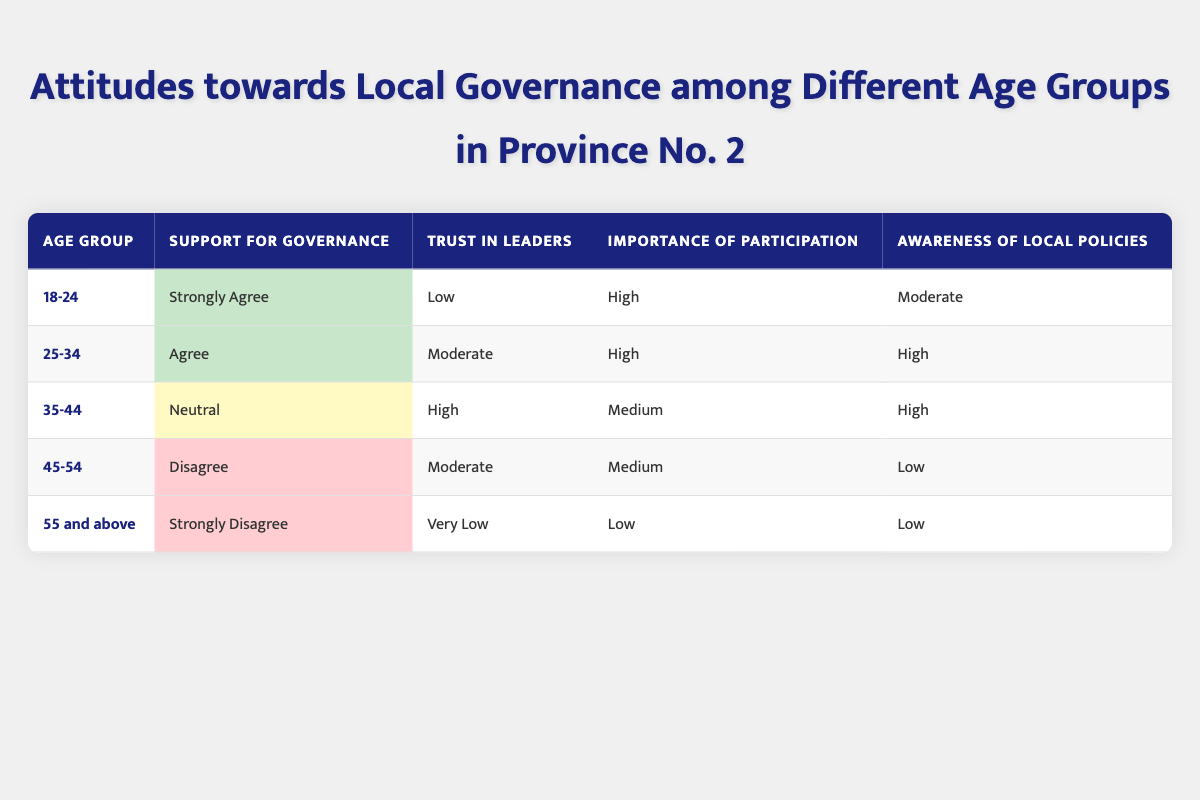What is the support for governance among the age group 25-34? The table shows that the support for governance among the age group 25-34 is "Agree."
Answer: Agree Which age group has the highest importance of participation? According to the table, both the 18-24 and 25-34 age groups have "High" importance of participation, which is the highest ranking in that column.
Answer: 18-24 and 25-34 Is trust in leaders lowest among the age group 55 and above? The table indicates that the trust in leaders for the age group 55 and above is "Very Low," which is indeed the lowest level listed in the table.
Answer: Yes What is the average level of awareness of local policies across all age groups? The awareness levels for each age group are: Moderate (18-24), High (25-34), High (35-44), Low (45-54), and Low (55 and above). To average these levels, we can assign numerical values: Moderate = 2, High = 3, Low = 1. Then the average is calculated as (2 + 3 + 3 + 1 + 1)/5 = 10/5 = 2, which corresponds to "Moderate."
Answer: Moderate Which age group has the most disagreement towards local governance? The table shows that the age group 55 and above has "Strongly Disagree," indicating the most disagreement towards local governance.
Answer: 55 and above How do the trust levels compare between the 35-44 age group and the 45-54 age group? The 35-44 age group has a trust level of "High" while the 45-54 age group has "Moderate," showing that trust is higher in the younger group compared to the older one.
Answer: Higher in 35-44 age group What is the difference in support for governance between the youngest and the oldest age groups? The youngest age group (18-24) has a support for governance of "Strongly Agree," which is a higher level than the "Strongly Disagree" expressed by the oldest age group (55 and above). In terms of qualitative levels, "Strongly Agree" is rated as 5 and "Strongly Disagree" is rated as 1. Therefore, the difference is 5 - 1 = 4, indicating a significant disparity.
Answer: 4 Does the 45-54 age group prioritize participation more than the 55 and above age group? The table indicates that the 45-54 age group has "Medium" importance of participation while the 55 and above group has "Low." This shows that the 45-54 age group does indeed prioritize participation more.
Answer: Yes What can be concluded about the general trend of attitudes towards local governance as age increases? Analyzing the table, we observe that as age increases from 18-24 to 55 and above, there is a trend of decreasing support for governance (from Strongly Agree to Strongly Disagree), decreasing trust in leaders (from Low to Very Low), and decreasing importance of participation (from High to Low). This indicates a general decline in positive attitudes towards local governance with age.
Answer: Declining attitudes with age 